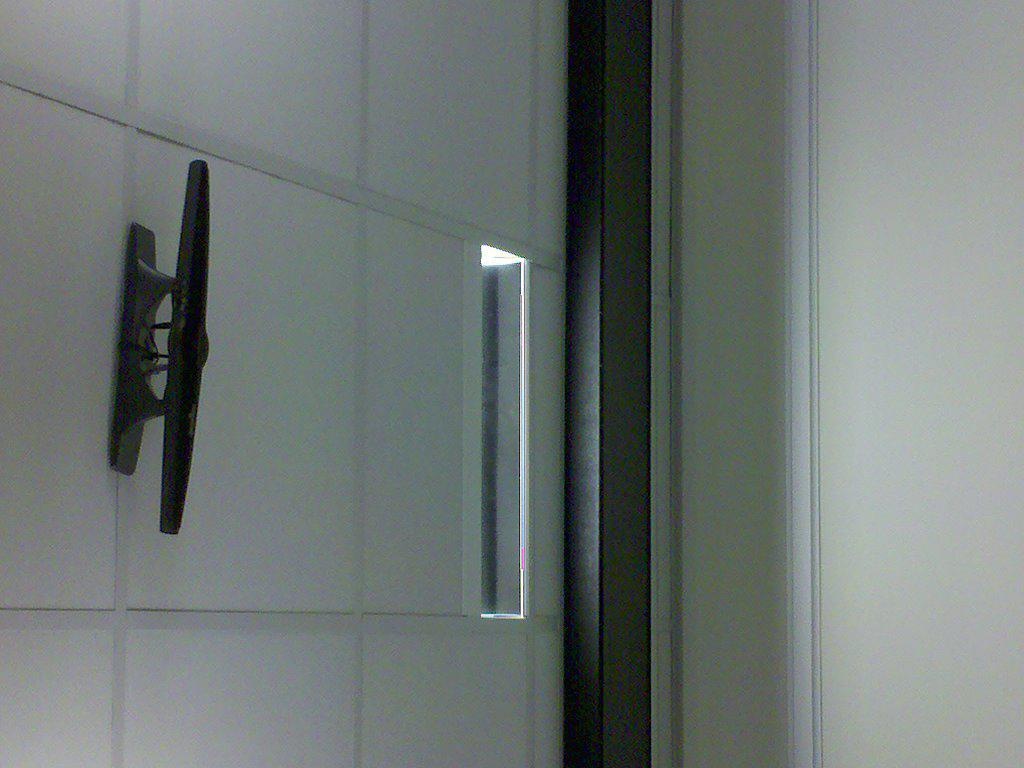Where was the image taken? The image was taken inside a building. What can be seen on the left side of the image? There is a gate on the left side of the image. What is the material of the gate's handle? The gate has a metal handle. What is on the right side of the image? There is a wall on the right side of the image. Reasoning: Let's think step by step by step in order to produce the conversation. We start by identifying the location of the image, which is inside a building. Then, we describe the main subjects and objects in the image, focusing on the gate and wall. Each question is designed to elicit a specific detail about the image that is known from the provided facts. Absurd Question/Answer: How many rings are visible on the queen's fingers in the image? There is no queen or rings present in the image. Can you describe the cats playing near the gate in the image? There are no cats present in the image. How many rings are visible on the queen's fingers in the image? There is no queen or rings present in the image. Can you describe the cats playing near the gate in the image? There are no cats present in the image. 